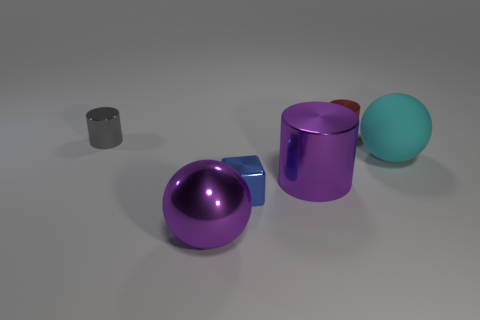Subtract all small gray metallic cylinders. How many cylinders are left? 2 Add 1 matte spheres. How many objects exist? 7 Subtract all red cylinders. How many cylinders are left? 2 Subtract 0 purple cubes. How many objects are left? 6 Subtract all spheres. How many objects are left? 4 Subtract 1 balls. How many balls are left? 1 Subtract all blue cylinders. Subtract all yellow blocks. How many cylinders are left? 3 Subtract all green cubes. How many gray cylinders are left? 1 Subtract all cyan balls. Subtract all small red metal cylinders. How many objects are left? 4 Add 3 big cylinders. How many big cylinders are left? 4 